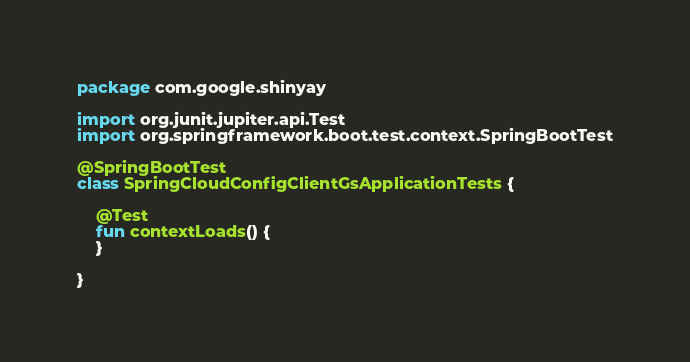Convert code to text. <code><loc_0><loc_0><loc_500><loc_500><_Kotlin_>package com.google.shinyay

import org.junit.jupiter.api.Test
import org.springframework.boot.test.context.SpringBootTest

@SpringBootTest
class SpringCloudConfigClientGsApplicationTests {

	@Test
	fun contextLoads() {
	}

}
</code> 